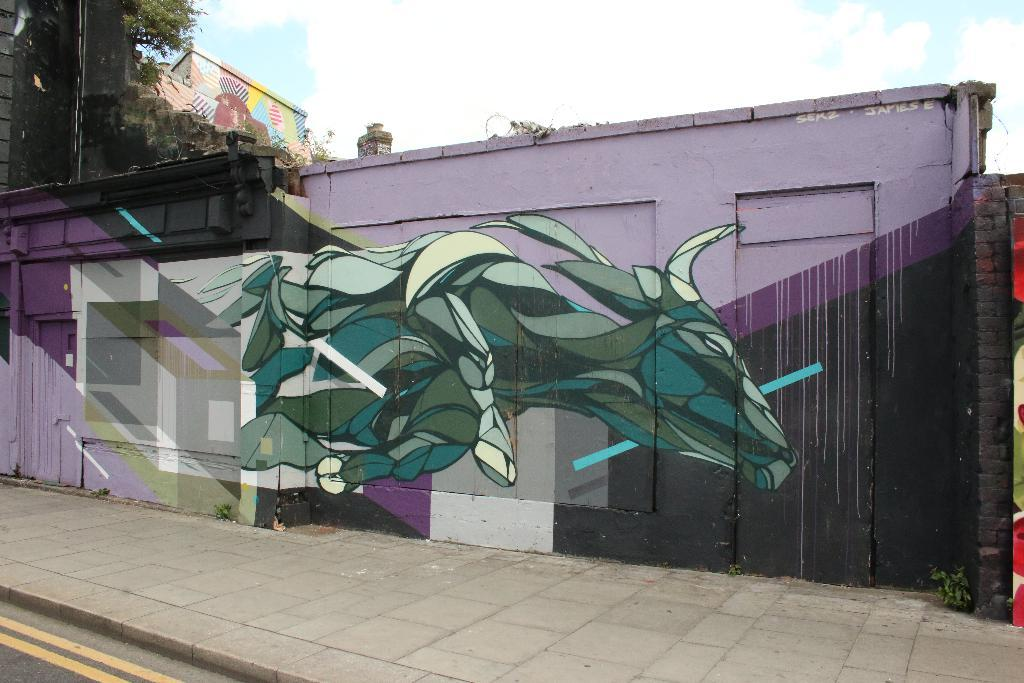What is depicted on the painting that is on the wall in the image? There is a painting of an animal on the wall in the image. What type of natural element can be seen in the image? There is a tree in the image. What is visible in the background of the image? The sky is visible in the background of the image. How many trains are visible in the image? There are no trains present in the image. What type of match is being played in the image? There is no match or any sports activity depicted in the image. 